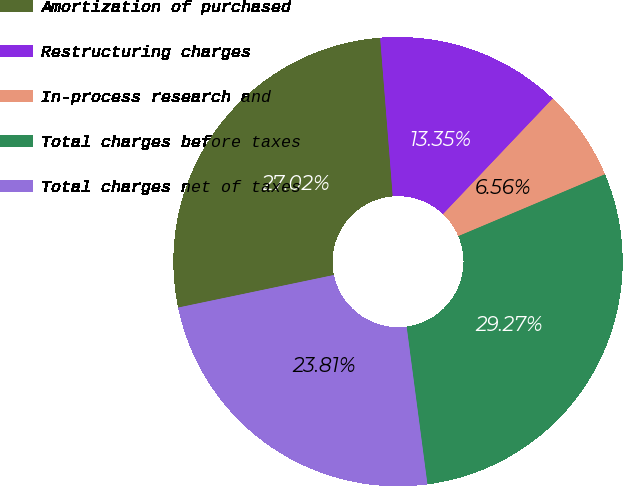Convert chart to OTSL. <chart><loc_0><loc_0><loc_500><loc_500><pie_chart><fcel>Amortization of purchased<fcel>Restructuring charges<fcel>In-process research and<fcel>Total charges before taxes<fcel>Total charges net of taxes<nl><fcel>27.02%<fcel>13.35%<fcel>6.56%<fcel>29.27%<fcel>23.81%<nl></chart> 